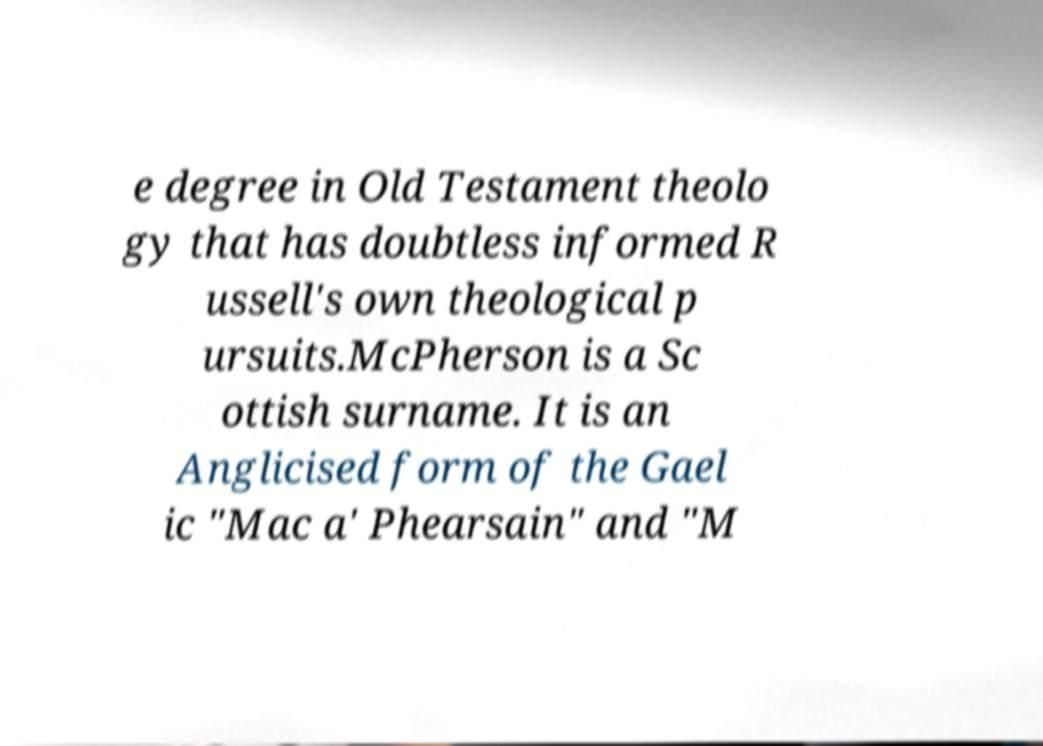Please read and relay the text visible in this image. What does it say? e degree in Old Testament theolo gy that has doubtless informed R ussell's own theological p ursuits.McPherson is a Sc ottish surname. It is an Anglicised form of the Gael ic "Mac a' Phearsain" and "M 